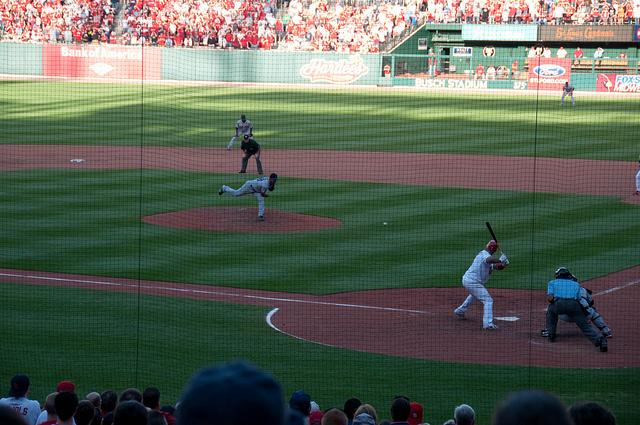How many players are you able to see on the field?
Short answer required. 5. Is a ball being thrown?
Concise answer only. Yes. What is the game being played?
Concise answer only. Baseball. 